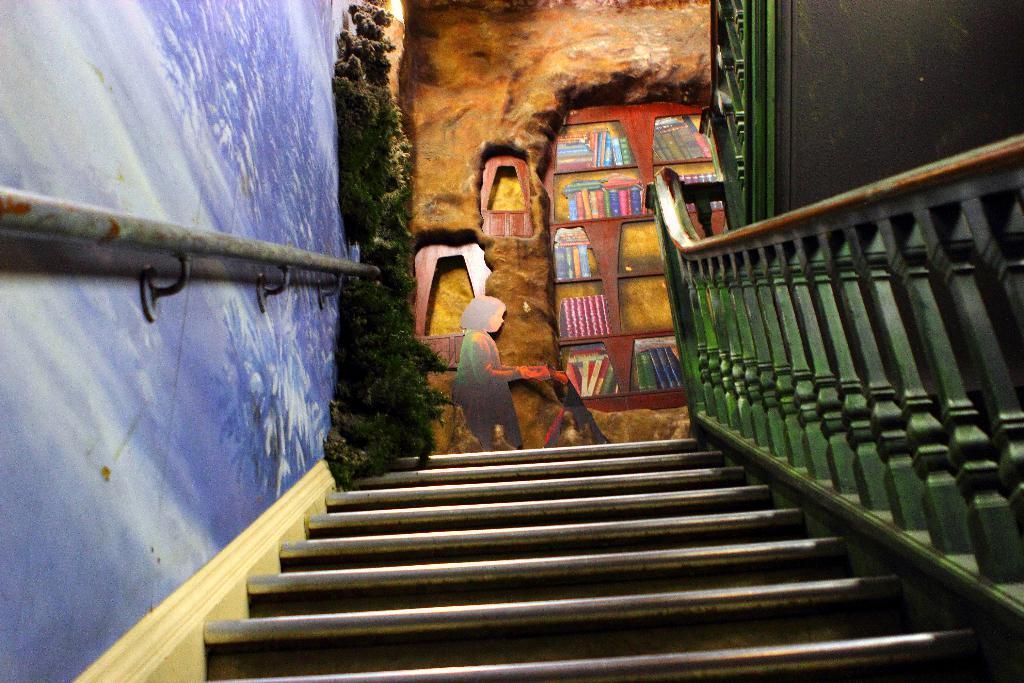In one or two sentences, can you explain what this image depicts? At the bottom, we see the staircase. On the right side, we see the stair railing. On the left side, we see a wall in blue color. Beside that, we see a plant pot. In the middle, we see a wall on which the posters or the stickers of the girl and the books are placed. 